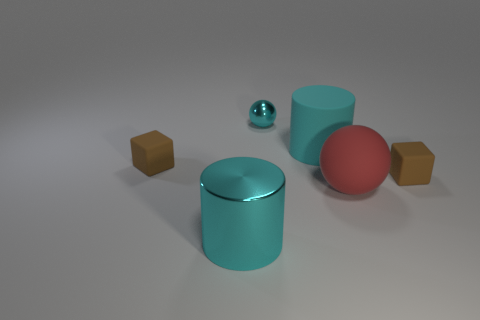There is a tiny matte block left of the small block that is right of the big cyan matte thing; what color is it?
Offer a very short reply. Brown. What is the size of the brown matte thing that is to the right of the cyan cylinder that is in front of the large thing to the right of the big cyan matte cylinder?
Your response must be concise. Small. Is the material of the big red thing the same as the large cyan cylinder that is behind the red sphere?
Make the answer very short. Yes. What is the size of the cyan object that is made of the same material as the large red thing?
Ensure brevity in your answer.  Large. Are there any other shiny objects of the same shape as the tiny cyan object?
Ensure brevity in your answer.  No. What number of things are either cylinders in front of the big ball or small objects?
Make the answer very short. 4. What is the size of the rubber object that is the same color as the tiny metal ball?
Offer a terse response. Large. Do the tiny object that is to the left of the tiny cyan metallic thing and the small matte object that is right of the cyan metal ball have the same color?
Provide a short and direct response. Yes. What is the size of the cyan rubber cylinder?
Provide a succinct answer. Large. How many small objects are red rubber objects or rubber objects?
Give a very brief answer. 2. 